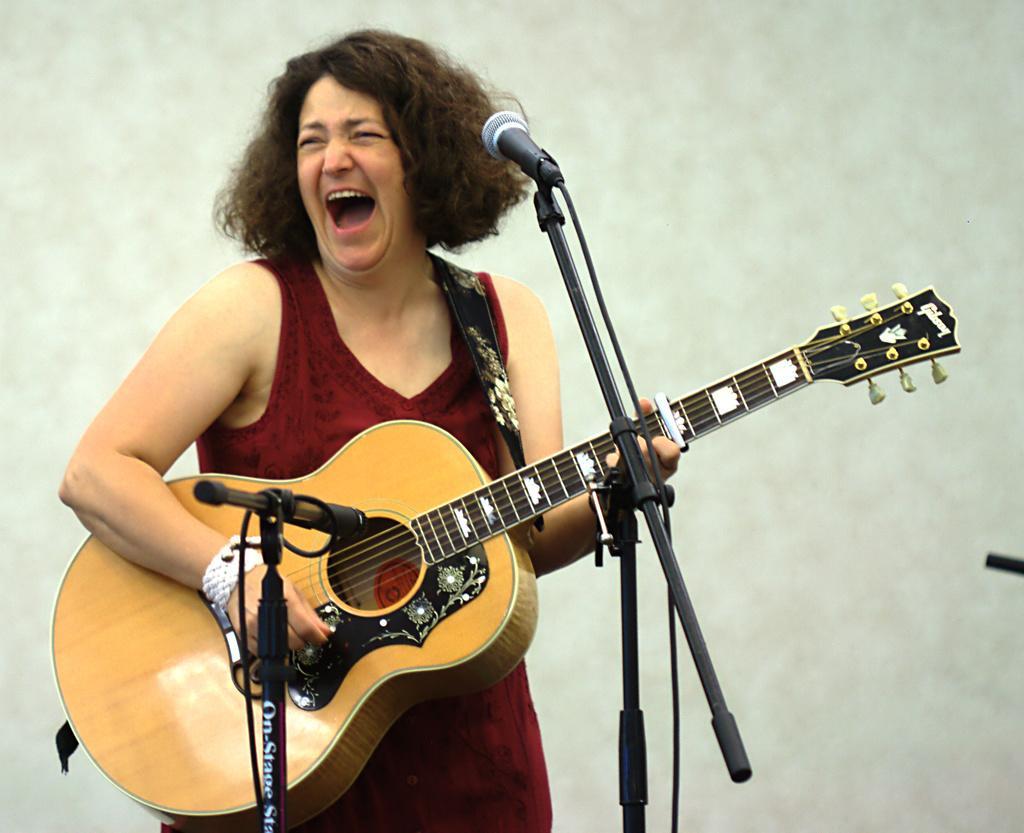Describe this image in one or two sentences. Here is a woman standing and playing guitar. This is the mike which is attached to the mike stand. 